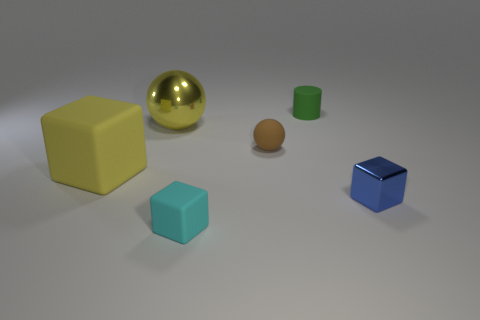Is there a big yellow thing of the same shape as the tiny cyan thing?
Give a very brief answer. Yes. There is a metal thing on the left side of the small object that is on the right side of the small green matte cylinder; how big is it?
Your answer should be compact. Large. What is the shape of the big yellow object on the right side of the block that is behind the tiny thing that is right of the tiny cylinder?
Give a very brief answer. Sphere. The yellow block that is the same material as the green cylinder is what size?
Make the answer very short. Large. Are there more small brown objects than small brown shiny cylinders?
Make the answer very short. Yes. There is a yellow object that is the same size as the yellow rubber cube; what is it made of?
Your answer should be compact. Metal. There is a sphere that is in front of the yellow metal object; does it have the same size as the tiny shiny thing?
Offer a terse response. Yes. How many balls are cyan objects or yellow metal objects?
Provide a short and direct response. 1. There is a thing that is right of the small green rubber cylinder; what material is it?
Offer a terse response. Metal. Is the number of cyan matte blocks less than the number of rubber blocks?
Keep it short and to the point. Yes. 